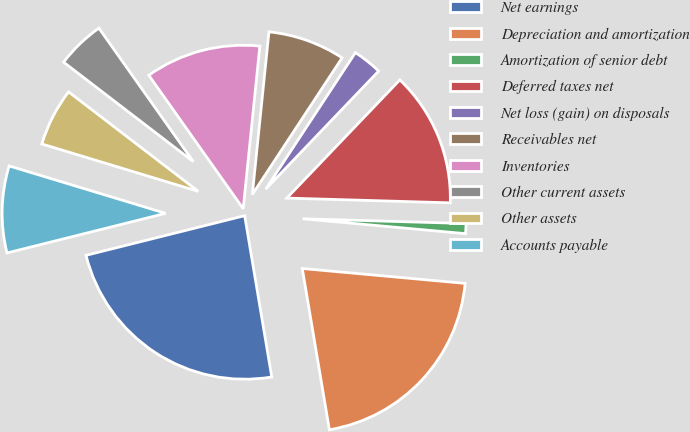<chart> <loc_0><loc_0><loc_500><loc_500><pie_chart><fcel>Net earnings<fcel>Depreciation and amortization<fcel>Amortization of senior debt<fcel>Deferred taxes net<fcel>Net loss (gain) on disposals<fcel>Receivables net<fcel>Inventories<fcel>Other current assets<fcel>Other assets<fcel>Accounts payable<nl><fcel>23.75%<fcel>20.9%<fcel>0.99%<fcel>13.32%<fcel>2.89%<fcel>7.63%<fcel>11.42%<fcel>4.79%<fcel>5.73%<fcel>8.58%<nl></chart> 